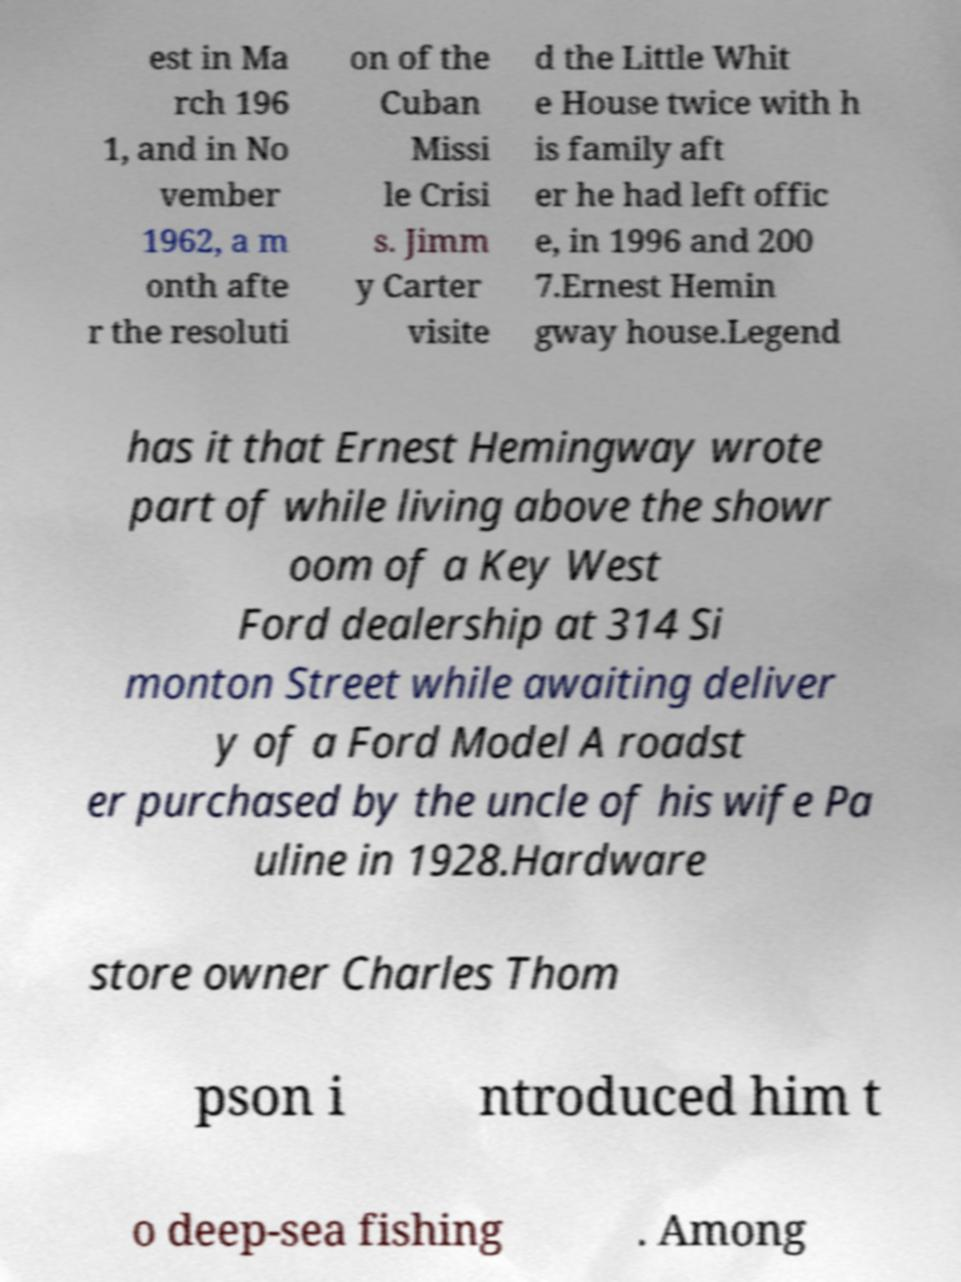I need the written content from this picture converted into text. Can you do that? est in Ma rch 196 1, and in No vember 1962, a m onth afte r the resoluti on of the Cuban Missi le Crisi s. Jimm y Carter visite d the Little Whit e House twice with h is family aft er he had left offic e, in 1996 and 200 7.Ernest Hemin gway house.Legend has it that Ernest Hemingway wrote part of while living above the showr oom of a Key West Ford dealership at 314 Si monton Street while awaiting deliver y of a Ford Model A roadst er purchased by the uncle of his wife Pa uline in 1928.Hardware store owner Charles Thom pson i ntroduced him t o deep-sea fishing . Among 